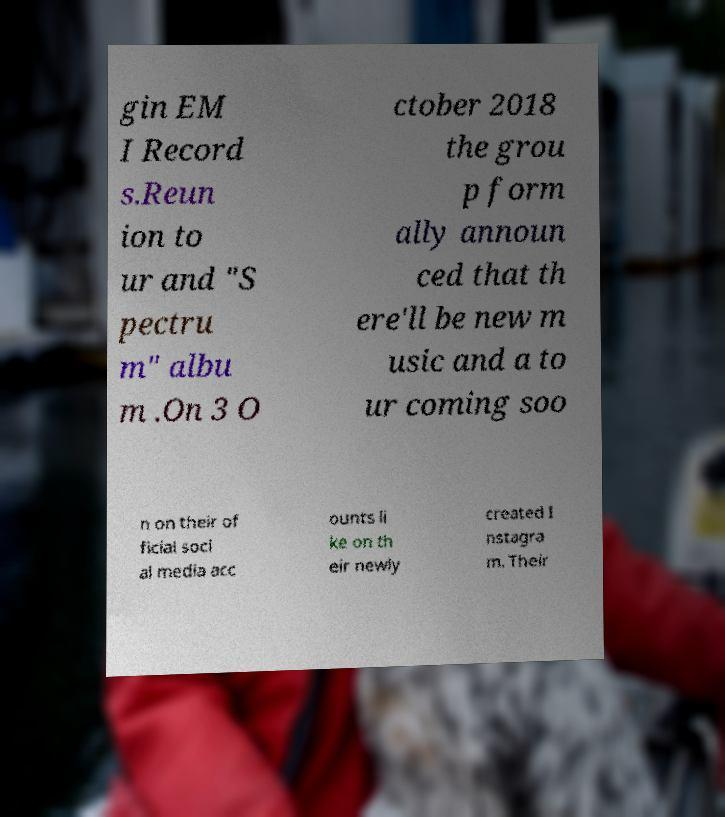Could you assist in decoding the text presented in this image and type it out clearly? gin EM I Record s.Reun ion to ur and "S pectru m" albu m .On 3 O ctober 2018 the grou p form ally announ ced that th ere'll be new m usic and a to ur coming soo n on their of ficial soci al media acc ounts li ke on th eir newly created I nstagra m. Their 